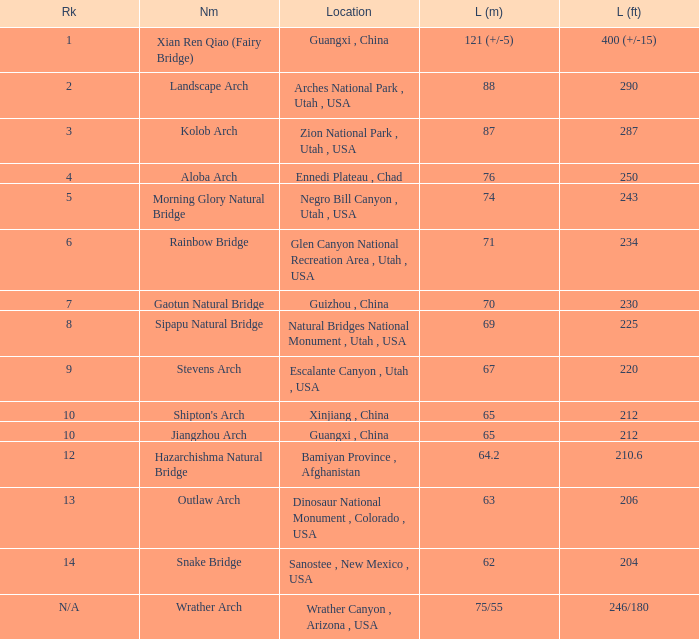What is the length in feet when the length in meters is 64.2? 210.6. 